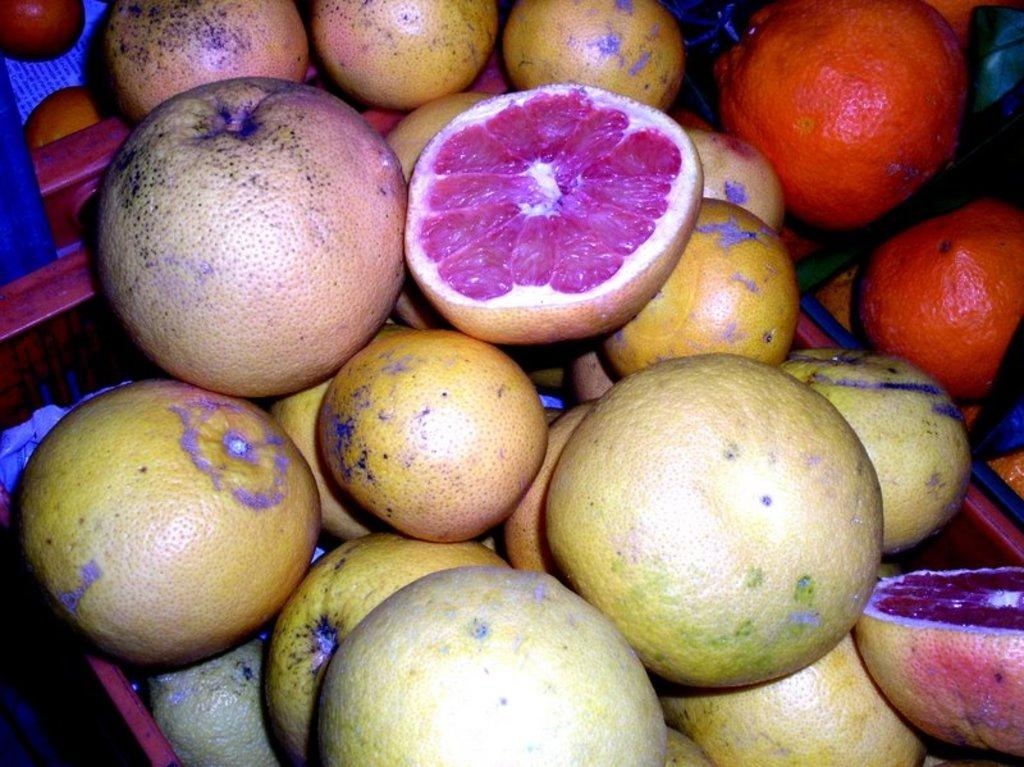What type of food can be seen in the image? There are fruits in the image. What colors are the fruits in the image? The fruits are yellow and orange in color. What type of sand can be seen in the image? There is no sand present in the image; it features fruits that are yellow and orange in color. What kind of test is being conducted in the image? There is no test being conducted in the image; it features fruits that are yellow and orange in color. 